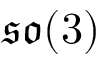<formula> <loc_0><loc_0><loc_500><loc_500>\mathfrak { s o } ( 3 )</formula> 